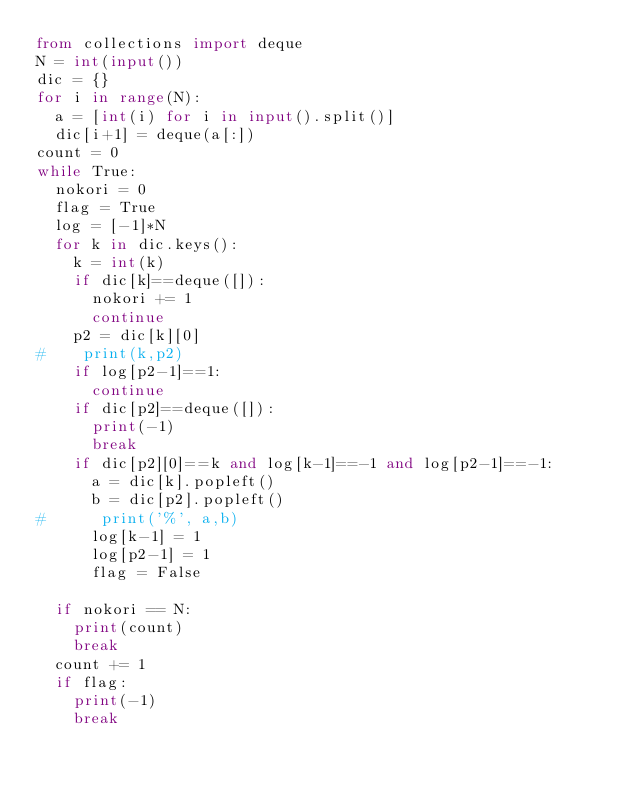Convert code to text. <code><loc_0><loc_0><loc_500><loc_500><_Python_>from collections import deque
N = int(input())
dic = {}
for i in range(N):
  a = [int(i) for i in input().split()]
  dic[i+1] = deque(a[:])
count = 0
while True:
  nokori = 0
  flag = True
  log = [-1]*N
  for k in dic.keys():
    k = int(k)
    if dic[k]==deque([]):
      nokori += 1
      continue
    p2 = dic[k][0]
#    print(k,p2)
    if log[p2-1]==1:
      continue
    if dic[p2]==deque([]):
      print(-1)
      break
    if dic[p2][0]==k and log[k-1]==-1 and log[p2-1]==-1:
      a = dic[k].popleft()
      b = dic[p2].popleft()
#      print('%', a,b)
      log[k-1] = 1
      log[p2-1] = 1
      flag = False
      
  if nokori == N:
    print(count)
    break
  count += 1
  if flag:
    print(-1)
    break</code> 